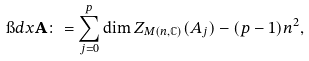Convert formula to latex. <formula><loc_0><loc_0><loc_500><loc_500>\i d x \mathbf A \colon = \sum _ { j = 0 } ^ { p } \dim Z _ { M ( n , \mathbb { C } ) } ( A _ { j } ) - ( p - 1 ) n ^ { 2 } ,</formula> 